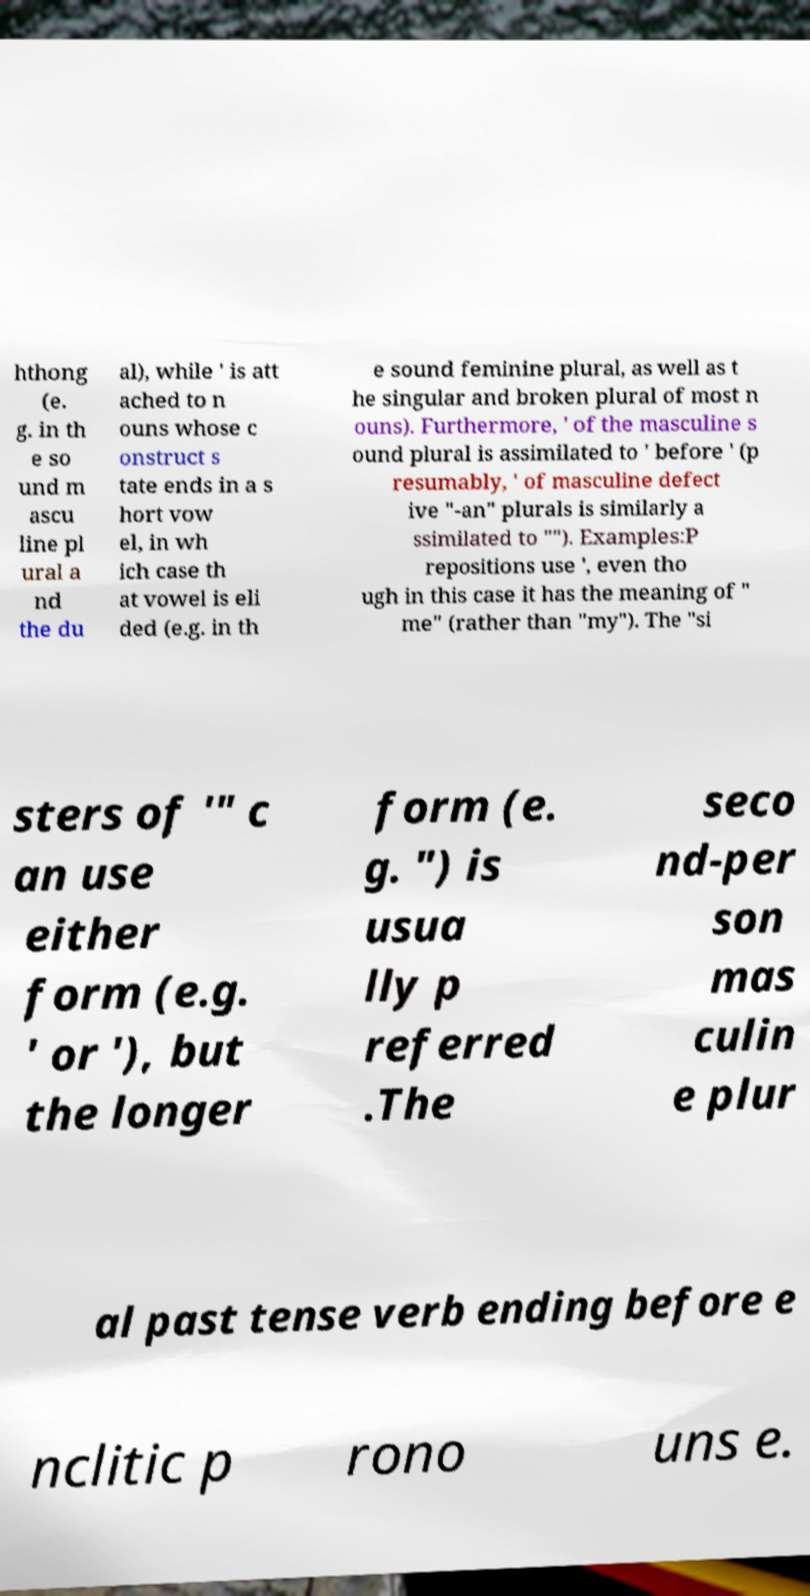There's text embedded in this image that I need extracted. Can you transcribe it verbatim? hthong (e. g. in th e so und m ascu line pl ural a nd the du al), while ' is att ached to n ouns whose c onstruct s tate ends in a s hort vow el, in wh ich case th at vowel is eli ded (e.g. in th e sound feminine plural, as well as t he singular and broken plural of most n ouns). Furthermore, ' of the masculine s ound plural is assimilated to ' before ' (p resumably, ' of masculine defect ive "-an" plurals is similarly a ssimilated to ""). Examples:P repositions use ', even tho ugh in this case it has the meaning of " me" (rather than "my"). The "si sters of '" c an use either form (e.g. ' or '), but the longer form (e. g. ") is usua lly p referred .The seco nd-per son mas culin e plur al past tense verb ending before e nclitic p rono uns e. 